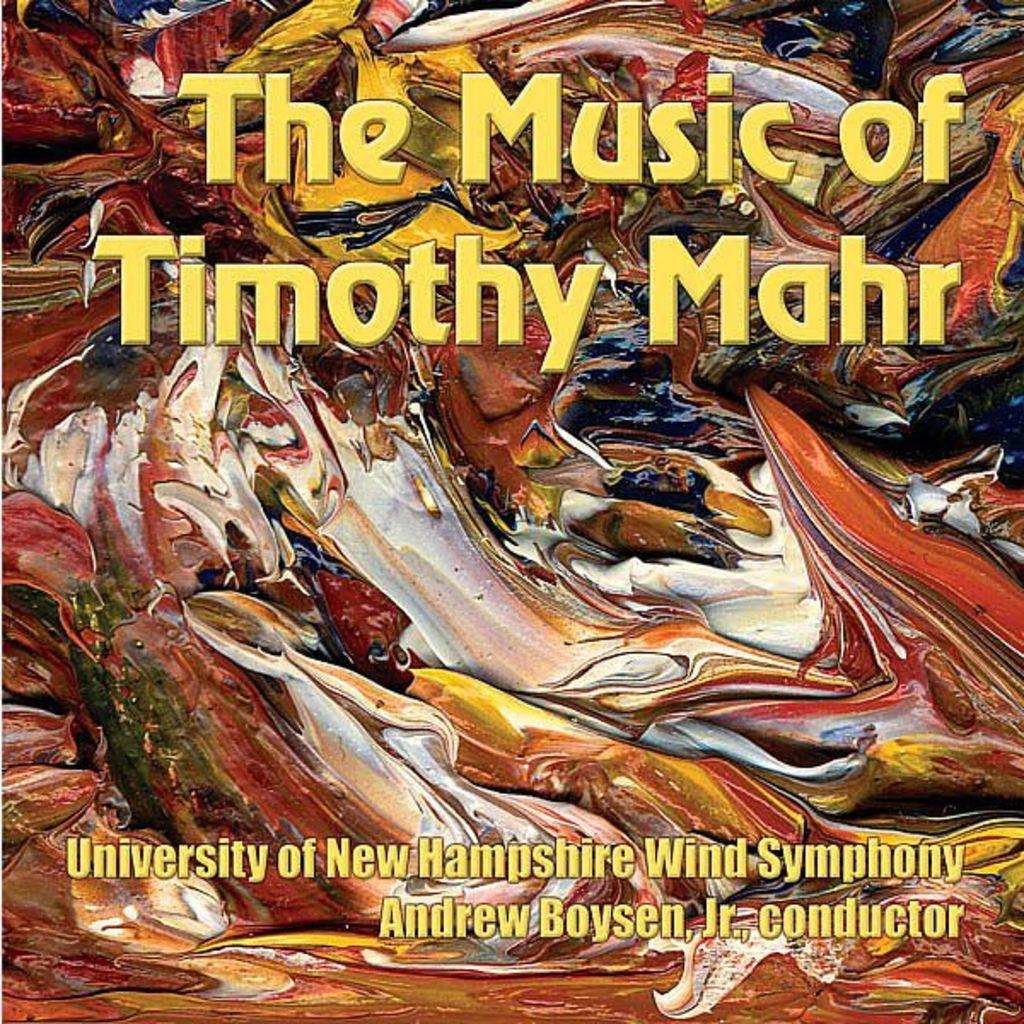<image>
Create a compact narrative representing the image presented. a piece of artwork with The Music of Timothy Mahr University of New Hampshire Wind Symphony Andrew Boysen, J., conductor 